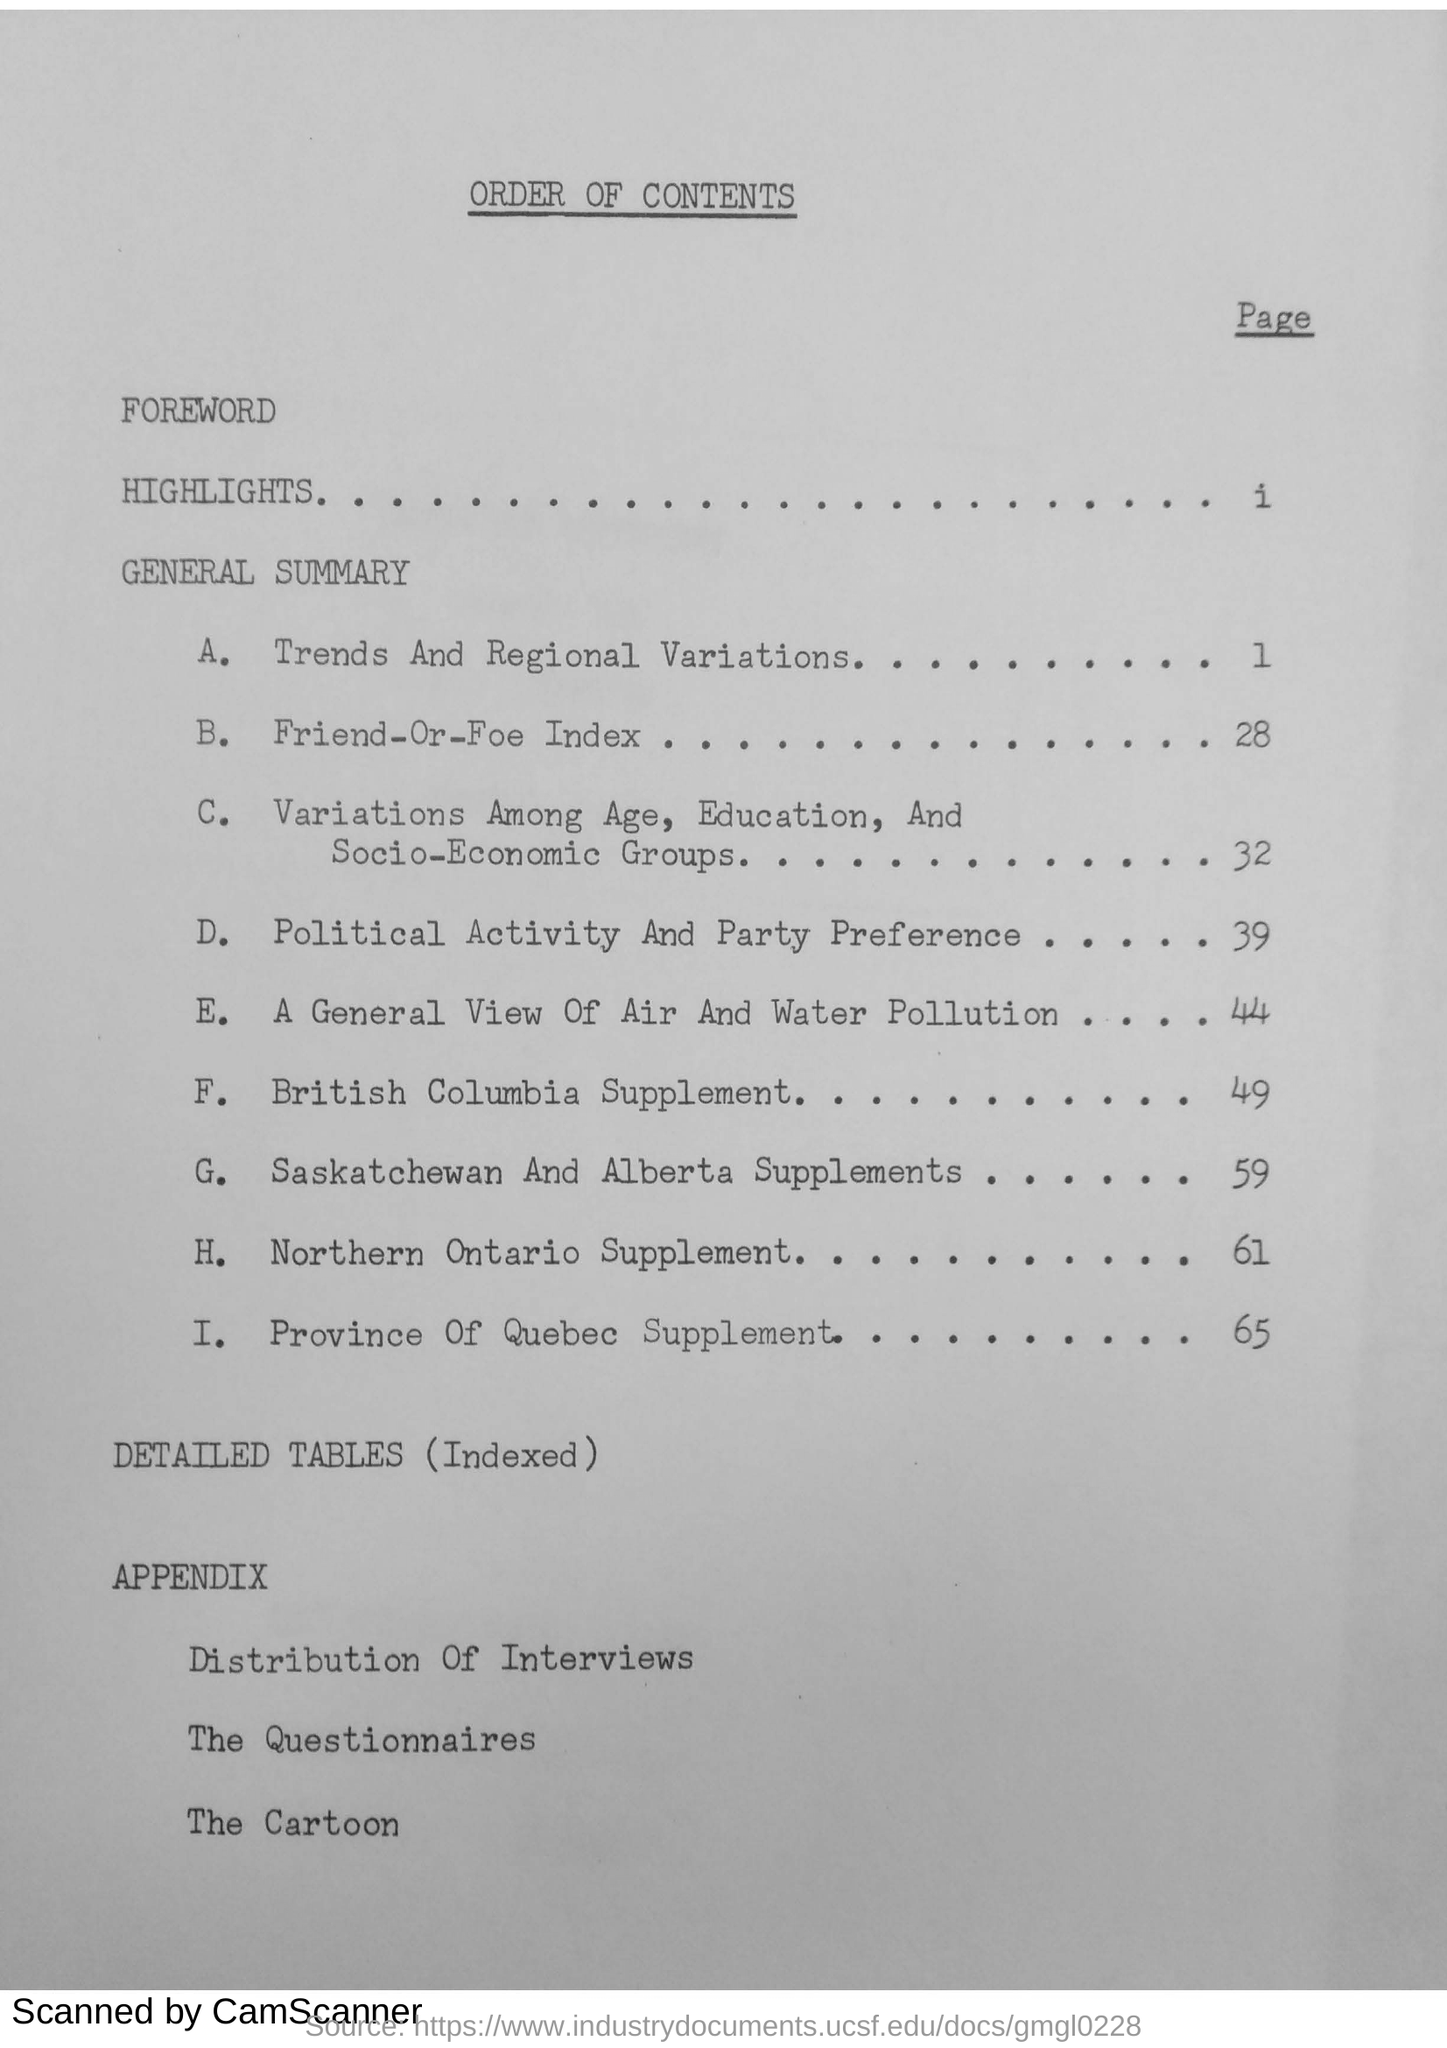Draw attention to some important aspects in this diagram. This document pertains to the topic of what the document is about, specifically outlining the order of contents within. The page number of the British Columbia Supplement is 49. 